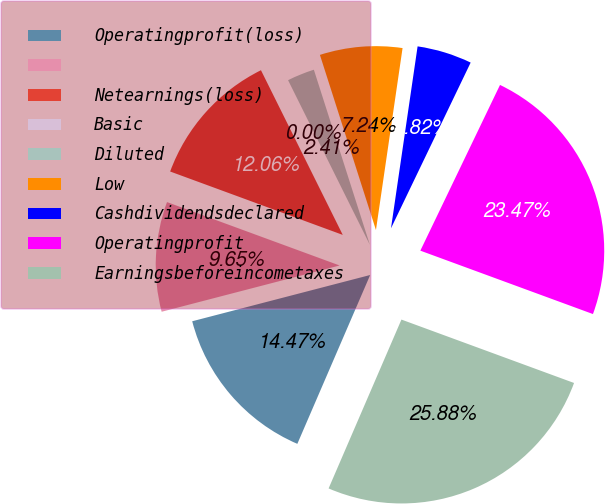Convert chart. <chart><loc_0><loc_0><loc_500><loc_500><pie_chart><fcel>Operatingprofit(loss)<fcel>Unnamed: 1<fcel>Netearnings(loss)<fcel>Basic<fcel>Diluted<fcel>Low<fcel>Cashdividendsdeclared<fcel>Operatingprofit<fcel>Earningsbeforeincometaxes<nl><fcel>14.47%<fcel>9.65%<fcel>12.06%<fcel>0.0%<fcel>2.41%<fcel>7.24%<fcel>4.82%<fcel>23.47%<fcel>25.88%<nl></chart> 